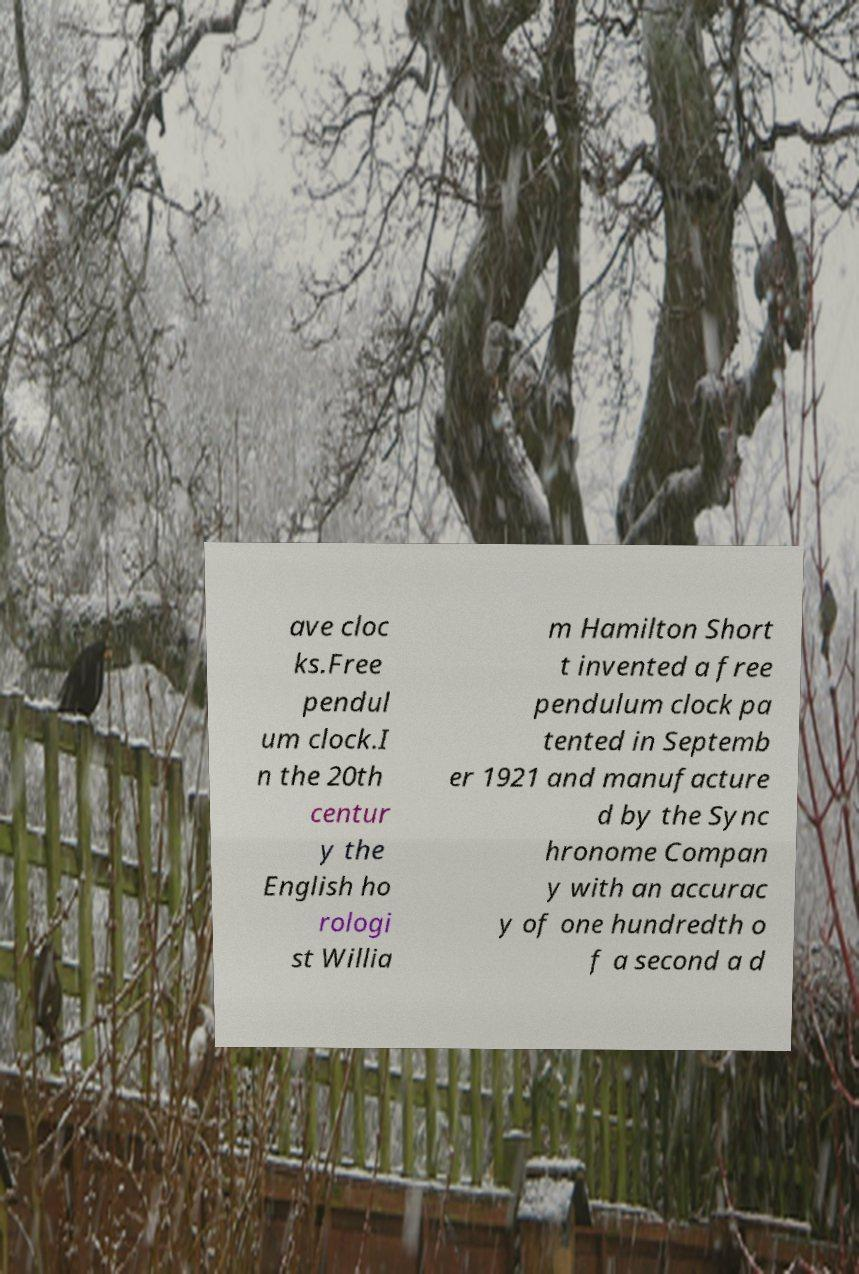Can you accurately transcribe the text from the provided image for me? ave cloc ks.Free pendul um clock.I n the 20th centur y the English ho rologi st Willia m Hamilton Short t invented a free pendulum clock pa tented in Septemb er 1921 and manufacture d by the Sync hronome Compan y with an accurac y of one hundredth o f a second a d 